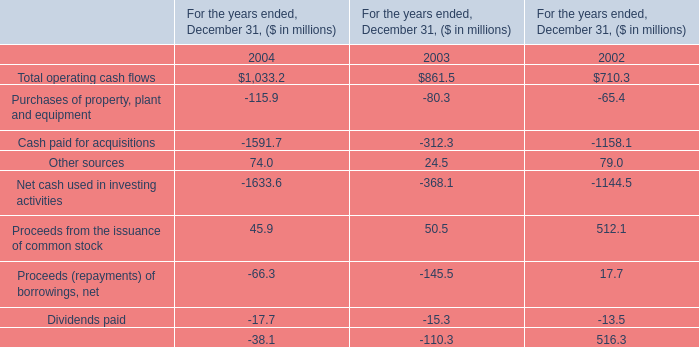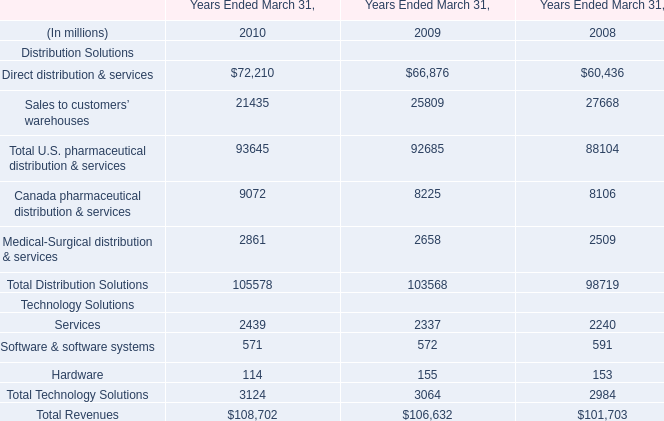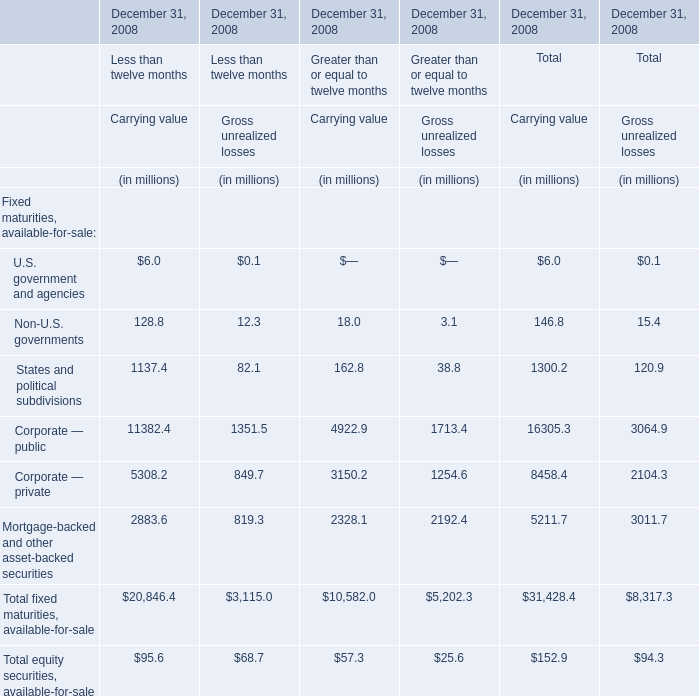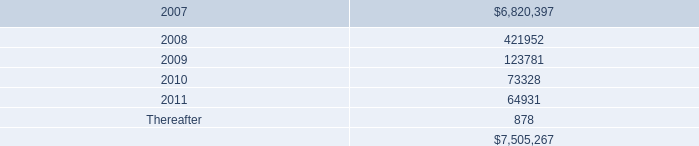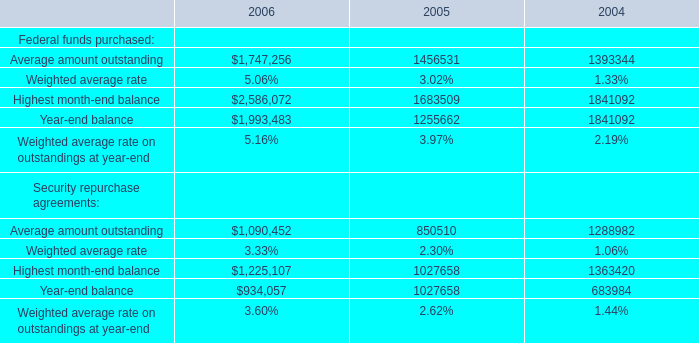What's the average of Sales to customers’ warehouses of Years Ended March 31, 2009, and Average amount outstanding of 2006 ? 
Computations: ((25809.0 + 1747256.0) / 2)
Answer: 886532.5. 